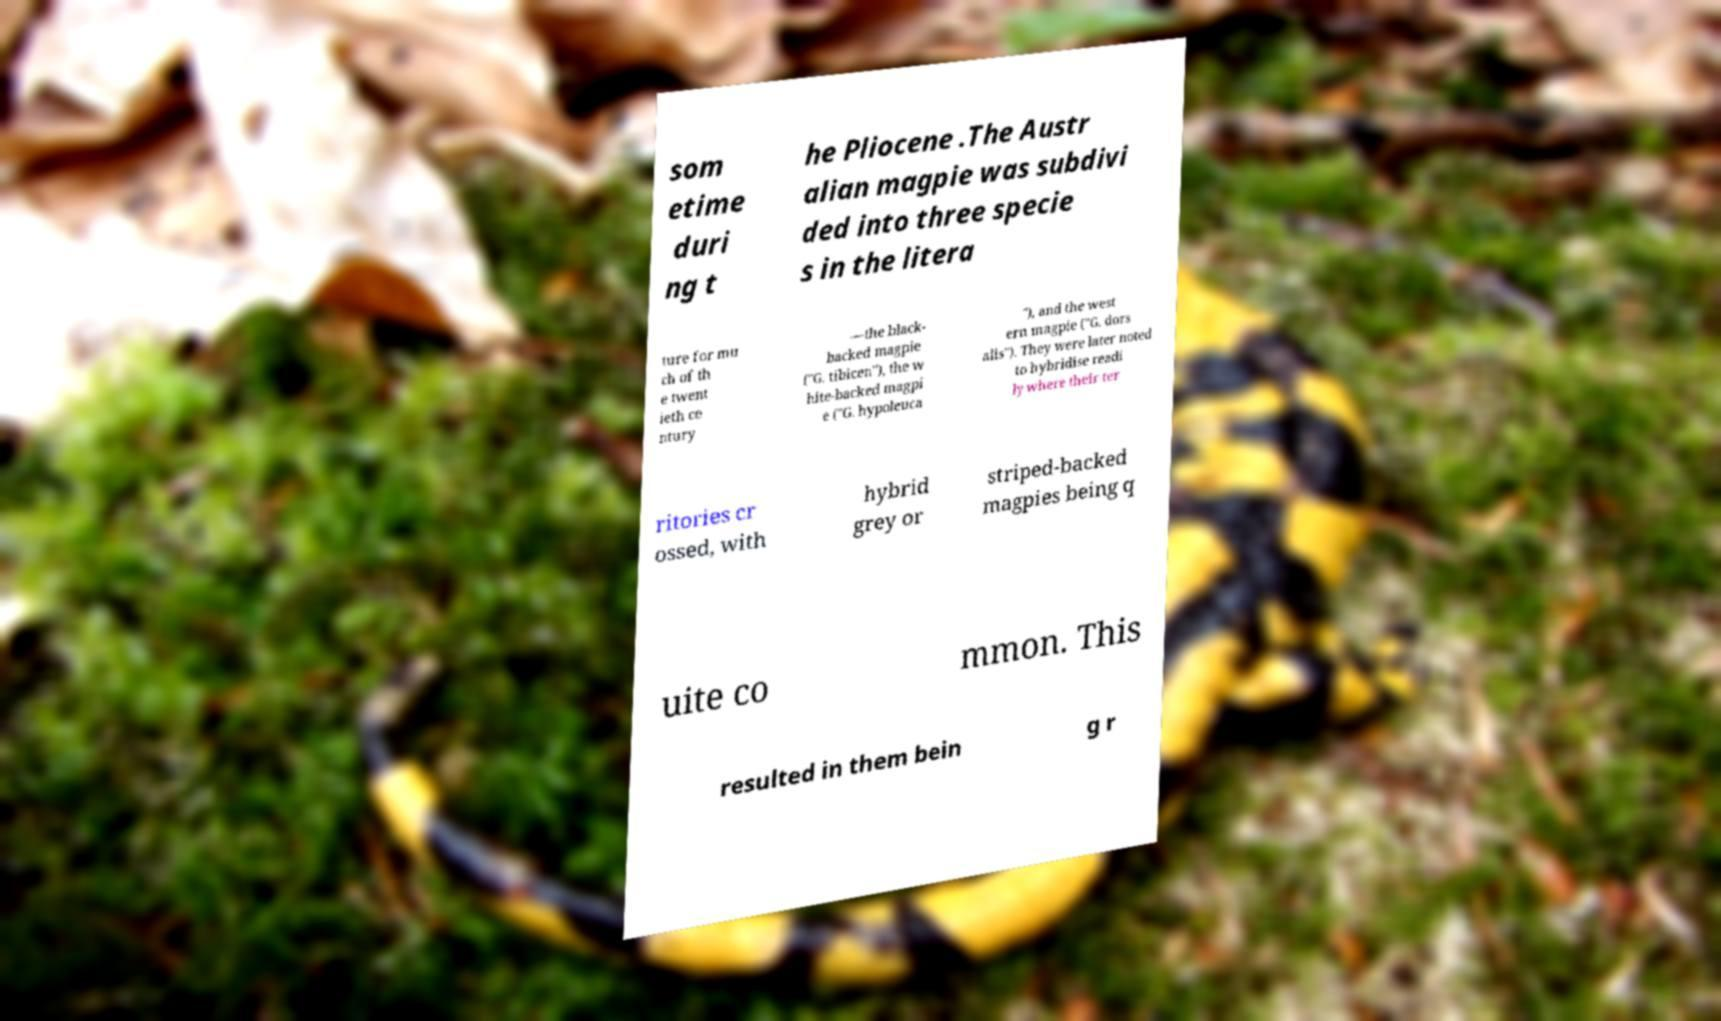Can you accurately transcribe the text from the provided image for me? som etime duri ng t he Pliocene .The Austr alian magpie was subdivi ded into three specie s in the litera ture for mu ch of th e twent ieth ce ntury —the black- backed magpie ("G. tibicen"), the w hite-backed magpi e ("G. hypoleuca "), and the west ern magpie ("G. dors alis"). They were later noted to hybridise readi ly where their ter ritories cr ossed, with hybrid grey or striped-backed magpies being q uite co mmon. This resulted in them bein g r 